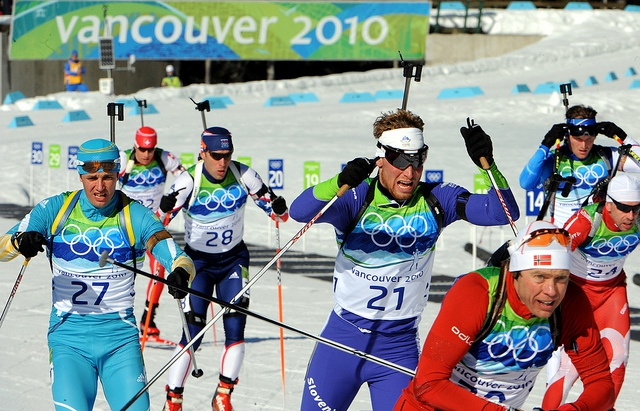Describe the objects in this image and their specific colors. I can see people in black, lightgray, navy, and darkblue tones, people in black, lightblue, teal, and lightgray tones, people in black, red, brown, and lightgray tones, people in black, lightgray, navy, and darkgray tones, and people in black, red, lightgray, darkgray, and brown tones in this image. 